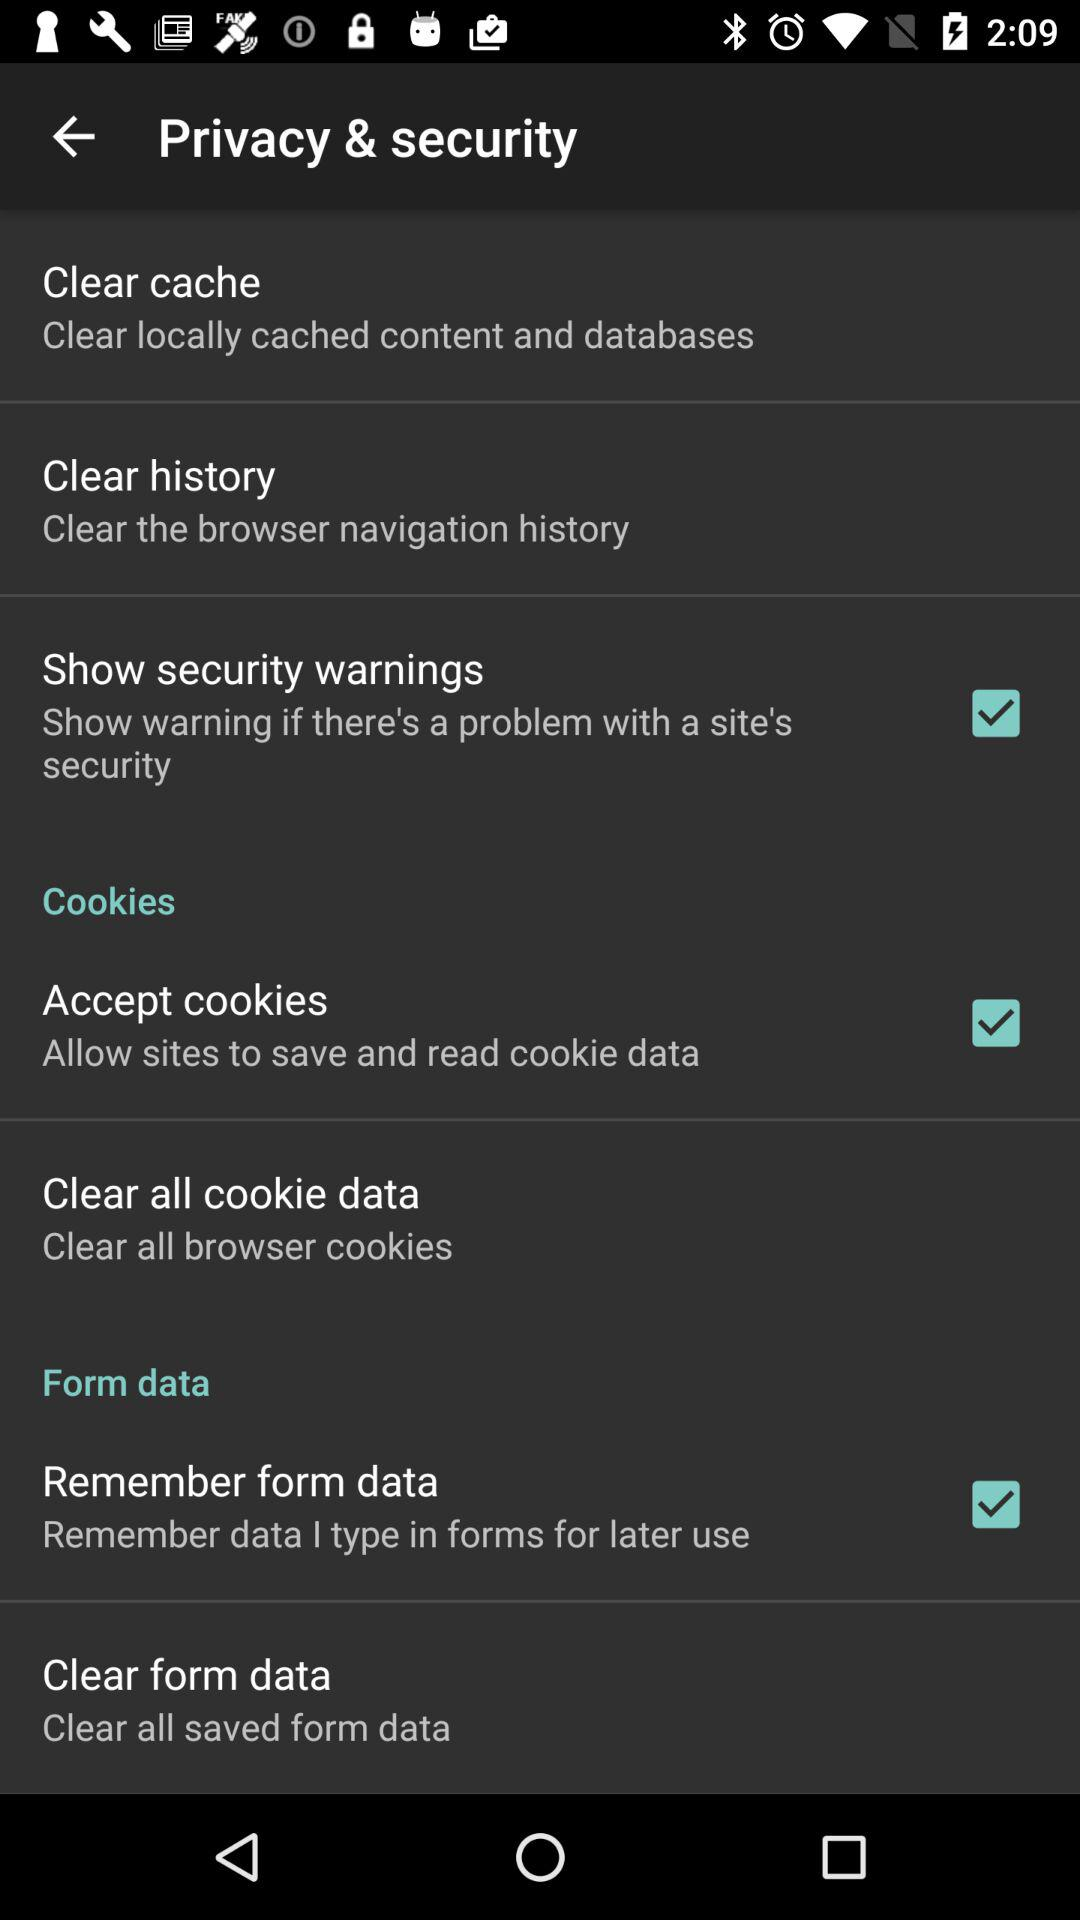How many options are there to clear the browser's data?
Answer the question using a single word or phrase. 4 